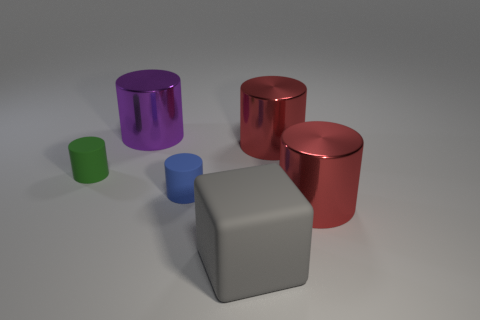Is there another large rubber cube of the same color as the block?
Ensure brevity in your answer.  No. Is there anything else that has the same size as the purple shiny cylinder?
Keep it short and to the point. Yes. How many rubber cylinders are the same color as the cube?
Your response must be concise. 0. Is the color of the large rubber block the same as the small thing on the right side of the small green matte object?
Offer a terse response. No. How many things are small blue matte cylinders or big cylinders that are to the right of the green object?
Give a very brief answer. 4. There is a cylinder that is left of the big metal cylinder that is to the left of the large gray cube; how big is it?
Provide a short and direct response. Small. Are there the same number of cylinders that are to the left of the gray block and red cylinders in front of the blue rubber cylinder?
Offer a very short reply. No. There is a red metallic cylinder in front of the tiny green matte cylinder; are there any metallic cylinders behind it?
Your response must be concise. Yes. What is the shape of the green object that is made of the same material as the small blue thing?
Offer a terse response. Cylinder. Is there any other thing that is the same color as the large matte thing?
Give a very brief answer. No. 